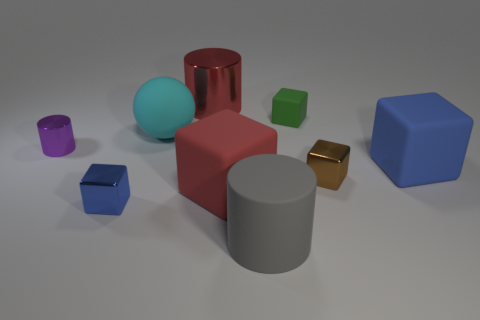Are there any other big rubber objects that have the same shape as the green thing?
Your answer should be compact. Yes. There is a blue object in front of the shiny thing that is right of the gray cylinder; are there any cylinders that are in front of it?
Keep it short and to the point. Yes. The cyan thing that is the same size as the blue rubber thing is what shape?
Ensure brevity in your answer.  Sphere. What is the color of the other large rubber thing that is the same shape as the large blue thing?
Your answer should be compact. Red. What number of things are tiny brown cylinders or small purple shiny things?
Provide a short and direct response. 1. There is a big red thing in front of the big blue rubber block; is it the same shape as the metallic object to the right of the large red cylinder?
Make the answer very short. Yes. What shape is the blue object that is on the left side of the red shiny thing?
Keep it short and to the point. Cube. Are there the same number of matte things left of the red cylinder and purple metal cylinders in front of the tiny blue shiny cube?
Offer a terse response. No. What number of things are either big cylinders or small metallic cubes that are to the left of the brown metal object?
Give a very brief answer. 3. The large matte thing that is right of the red rubber cube and left of the small brown shiny cube has what shape?
Give a very brief answer. Cylinder. 